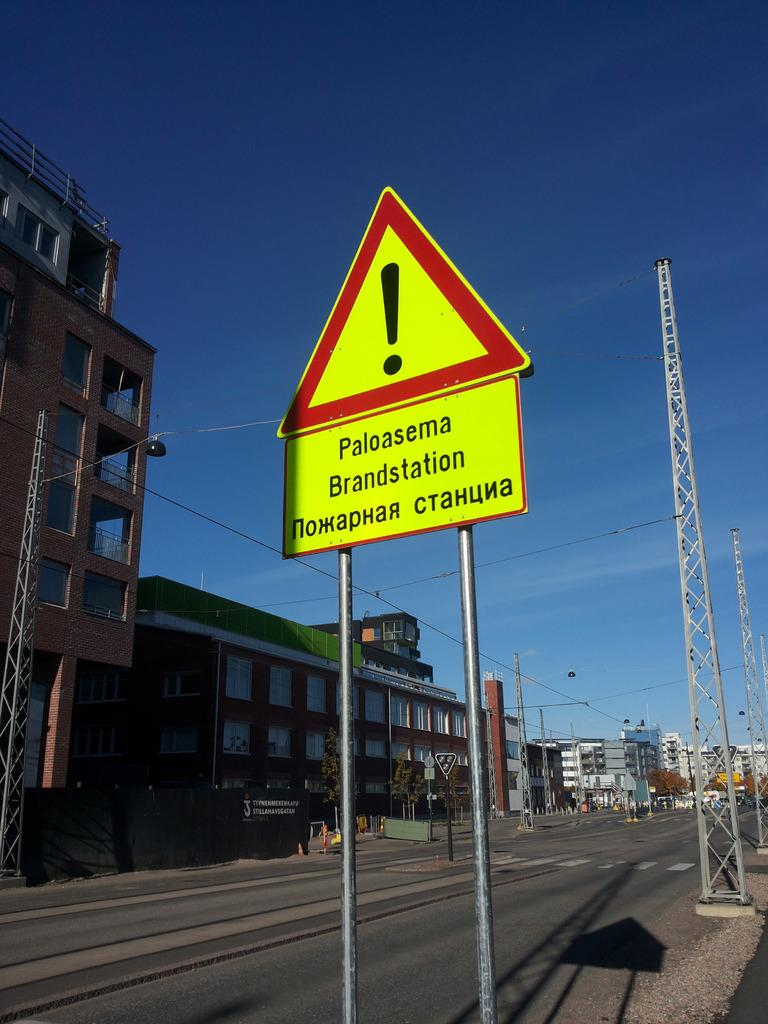<image>
Give a short and clear explanation of the subsequent image. a caution sign labeled Paloasema and other words, possibly in russian, is on the highway 